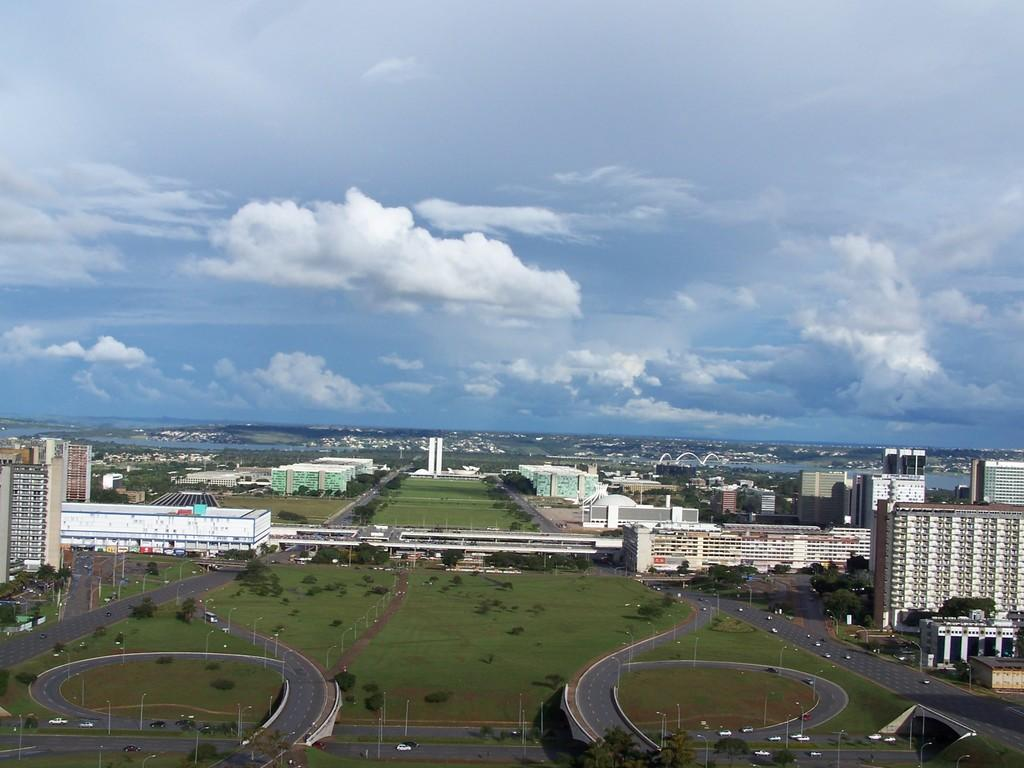Where was the image taken? The image is clicked outside. From what height was the image taken? The image appears to be taken from a plane. What type of structures can be seen in the image? There are buildings in the image. What type of terrain is visible in the image? Grass is visible in the image. What type of infrastructure is present in the image? Roads are present in the image. What is visible in the sky in the image? There are clouds in the sky. What type of flesh can be seen hanging from the buildings in the image? There is no flesh present in the image; it features buildings, grass, roads, and clouds. Can you tell me how many clams are visible on the grass in the image? There are no clams visible on the grass in the image; it features grass, buildings, roads, and clouds. 